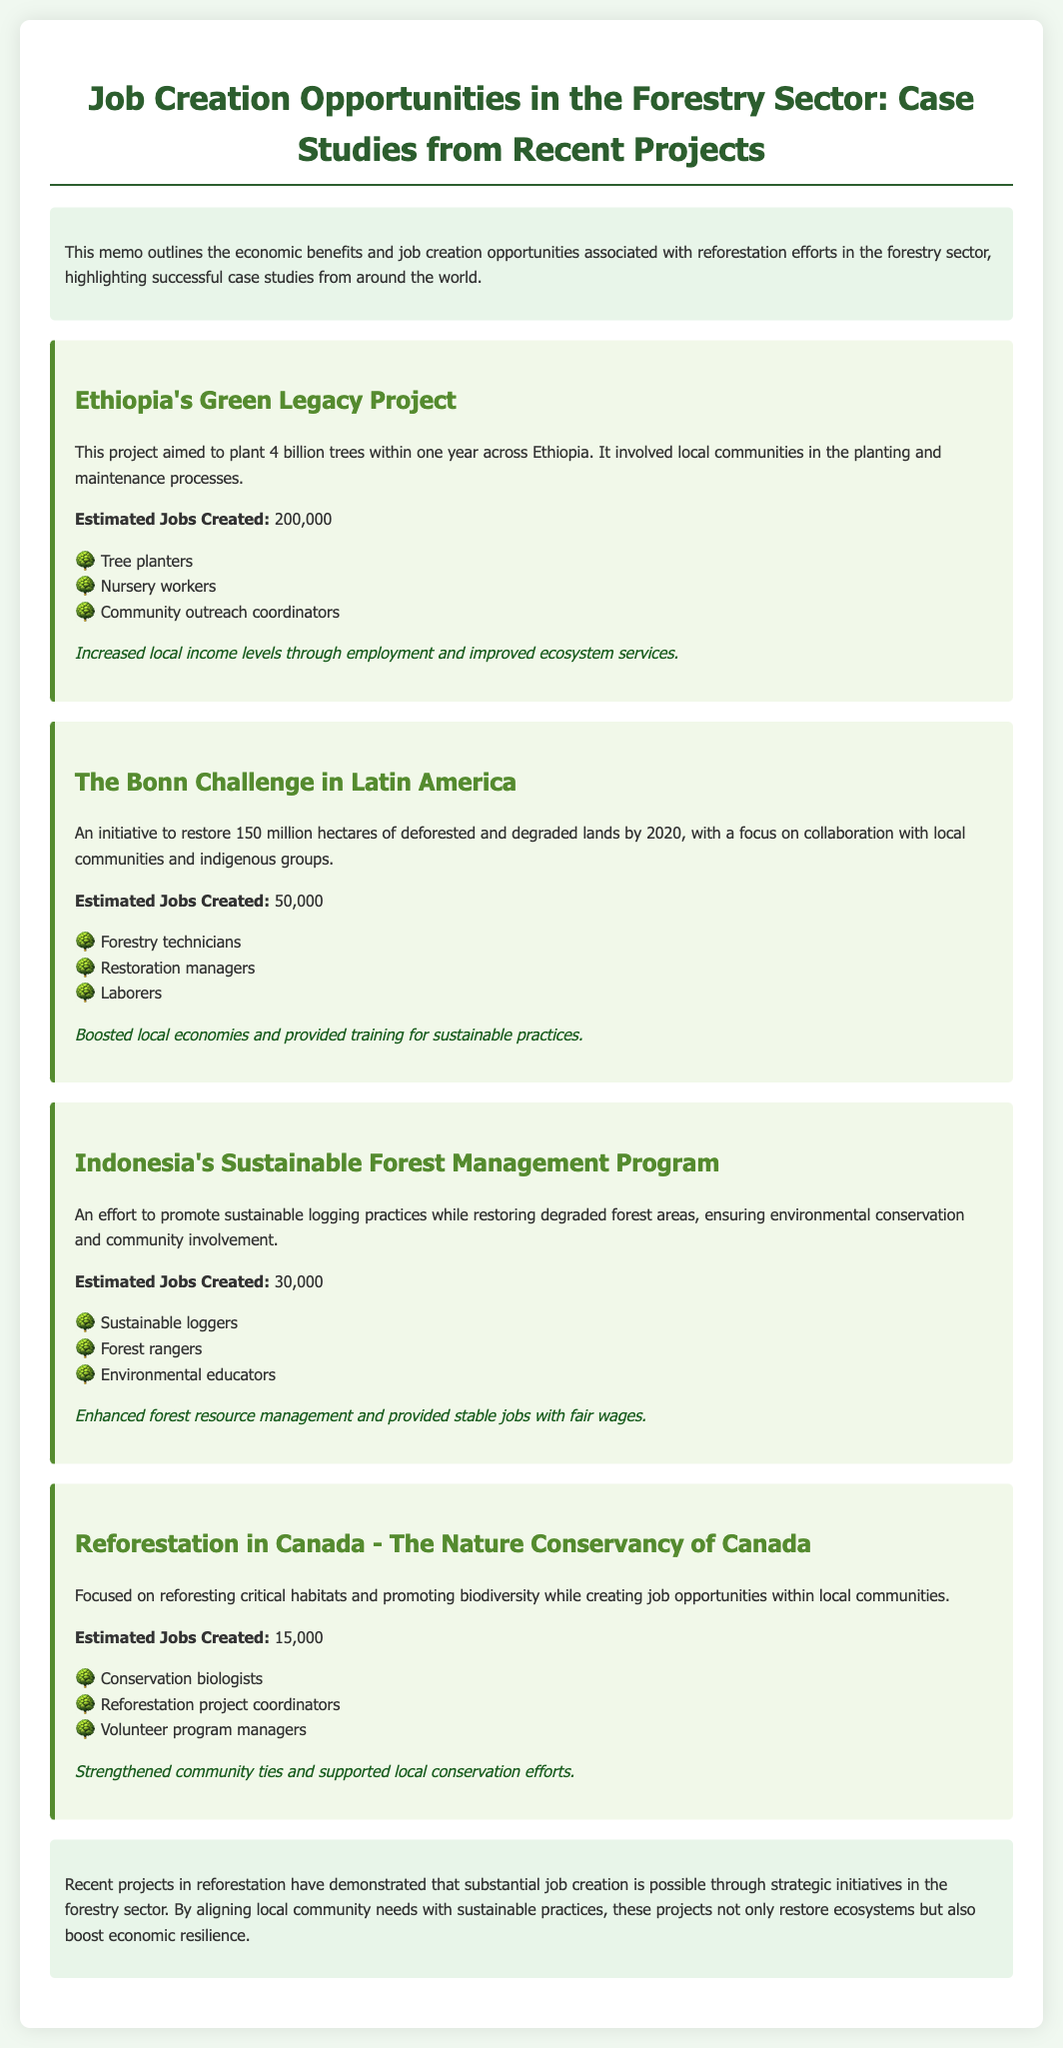What is the title of the memo? The title of the memo can be found at the top of the document and is a summary of its content regarding job creation in the forestry sector.
Answer: Job Creation Opportunities in the Forestry Sector: Case Studies from Recent Projects How many trees were aimed to be planted in Ethiopia's Green Legacy Project? The document specifies the goal of the project in terms of the number of trees to be planted within a year in Ethiopia.
Answer: 4 billion trees What is the estimated number of jobs created by The Bonn Challenge in Latin America? The estimate for jobs created by this initiative is mentioned in the section related to the case study on The Bonn Challenge.
Answer: 50,000 What types of workers were involved in Indonesia's Sustainable Forest Management Program? The document lists specific job roles associated with the program, which highlight the various types of work involved in the initiative.
Answer: Sustainable loggers, Forest rangers, Environmental educators Which project created the least number of jobs? By comparing the estimated jobs created in each case study, we can determine which project has the lowest number.
Answer: Reforestation in Canada - The Nature Conservancy of Canada What is the main economic benefit highlighted in the conclusion of the memo? The conclusion emphasizes a specific benefit of the projects discussed in terms of their impact on economic resilience and community alignment.
Answer: Job creation How is community involvement described in The Bonn Challenge? The document discusses the type of communities engaged in the project and highlights collaboration as a central theme in the initiative.
Answer: Local communities and indigenous groups What color is associated with the headings in the memo? The document's style indicates the color used for headings, which contributes to the overall aesthetic and readability.
Answer: Dark green 